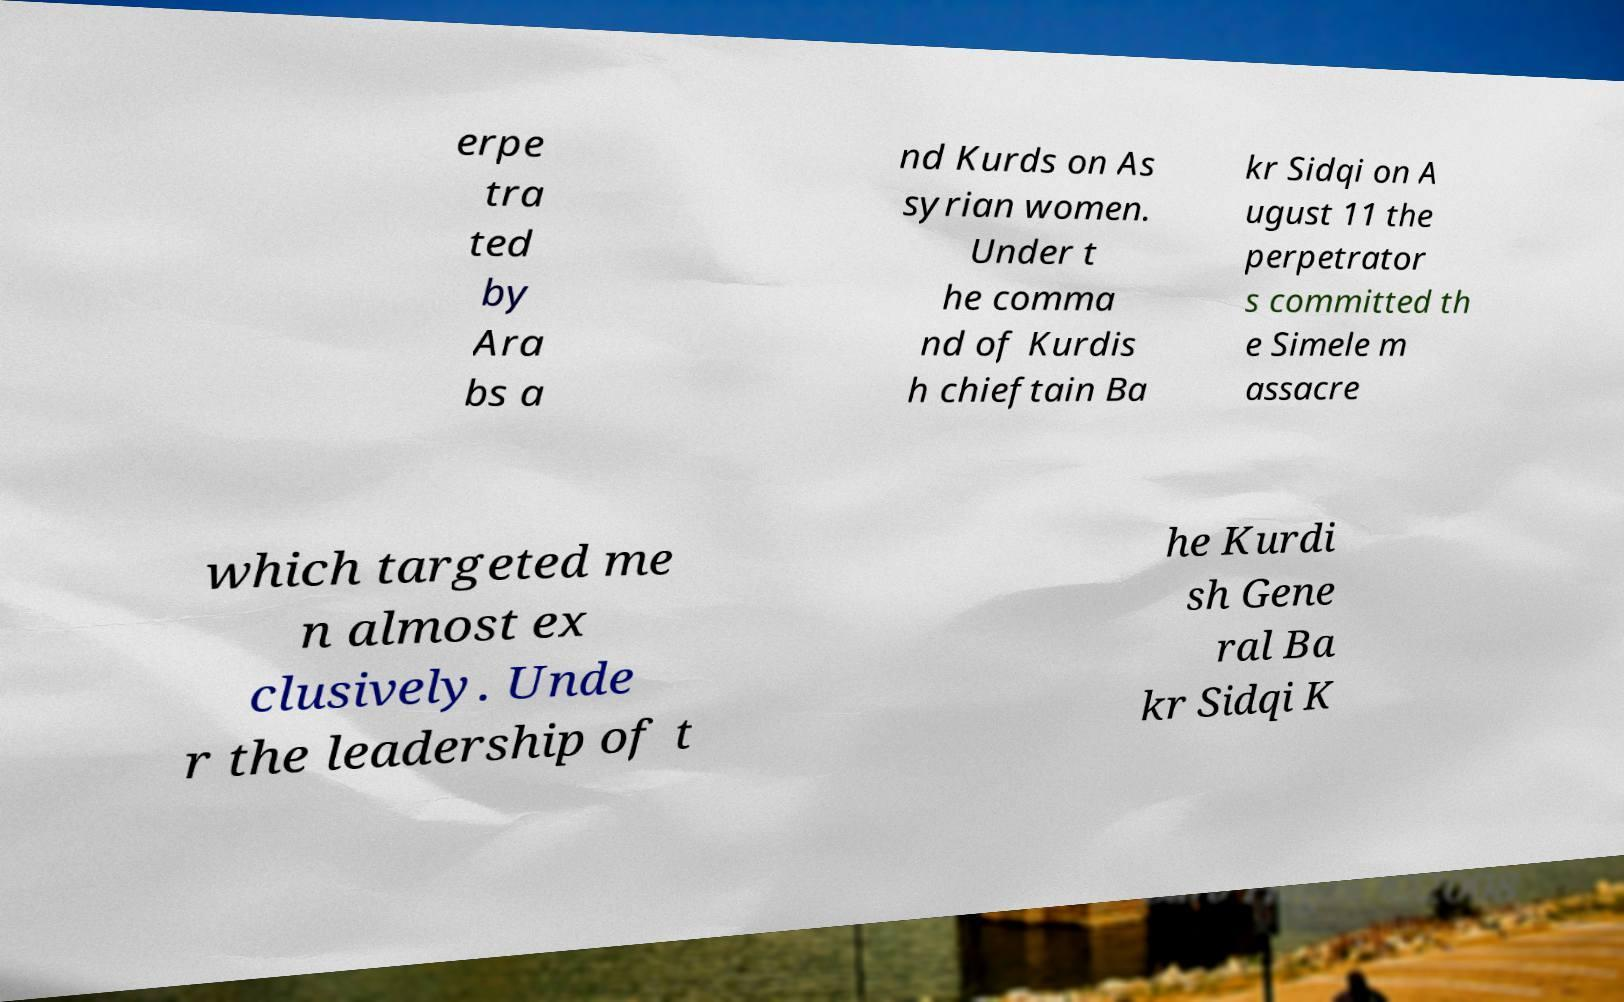What messages or text are displayed in this image? I need them in a readable, typed format. erpe tra ted by Ara bs a nd Kurds on As syrian women. Under t he comma nd of Kurdis h chieftain Ba kr Sidqi on A ugust 11 the perpetrator s committed th e Simele m assacre which targeted me n almost ex clusively. Unde r the leadership of t he Kurdi sh Gene ral Ba kr Sidqi K 